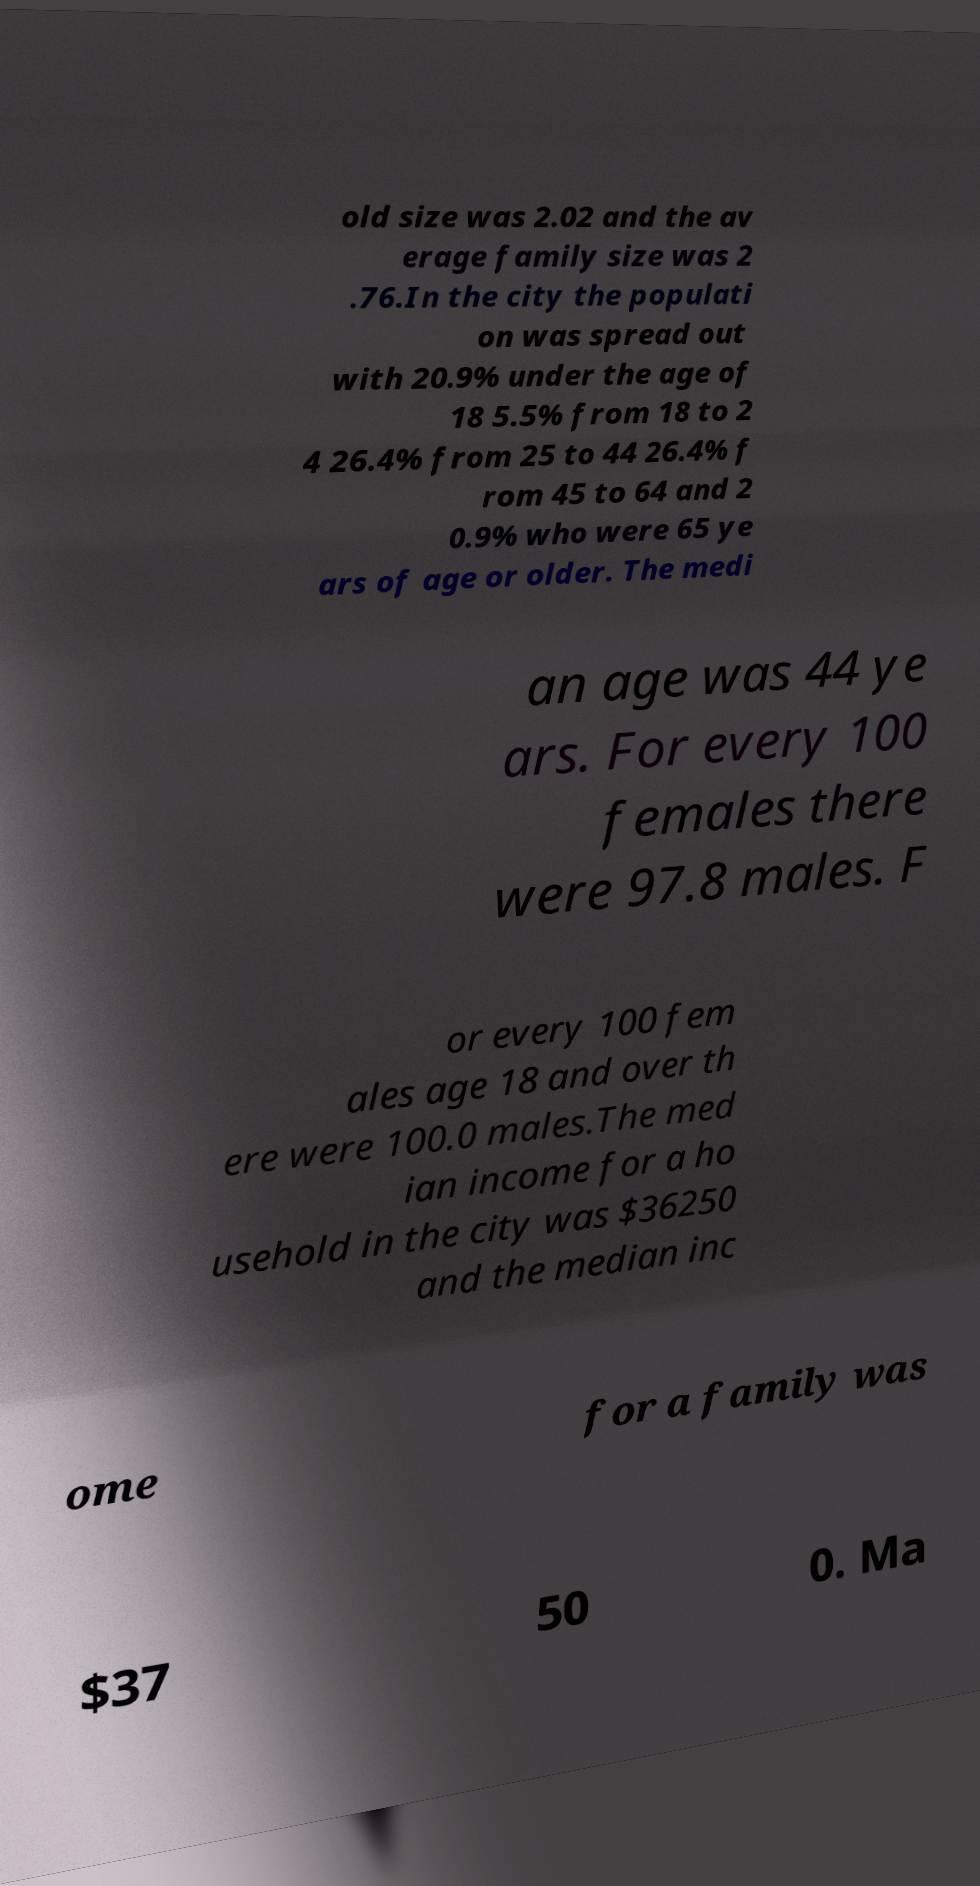Can you accurately transcribe the text from the provided image for me? old size was 2.02 and the av erage family size was 2 .76.In the city the populati on was spread out with 20.9% under the age of 18 5.5% from 18 to 2 4 26.4% from 25 to 44 26.4% f rom 45 to 64 and 2 0.9% who were 65 ye ars of age or older. The medi an age was 44 ye ars. For every 100 females there were 97.8 males. F or every 100 fem ales age 18 and over th ere were 100.0 males.The med ian income for a ho usehold in the city was $36250 and the median inc ome for a family was $37 50 0. Ma 